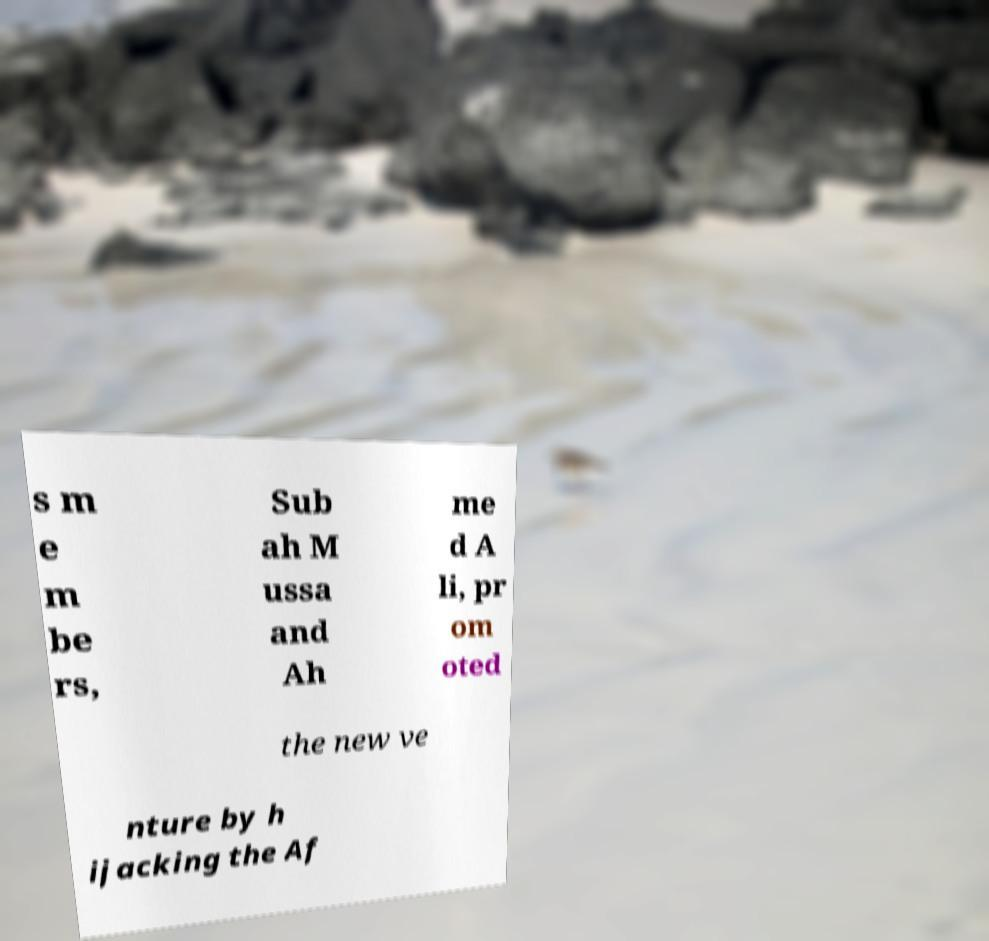For documentation purposes, I need the text within this image transcribed. Could you provide that? s m e m be rs, Sub ah M ussa and Ah me d A li, pr om oted the new ve nture by h ijacking the Af 